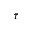<formula> <loc_0><loc_0><loc_500><loc_500>\bar { \tau }</formula> 